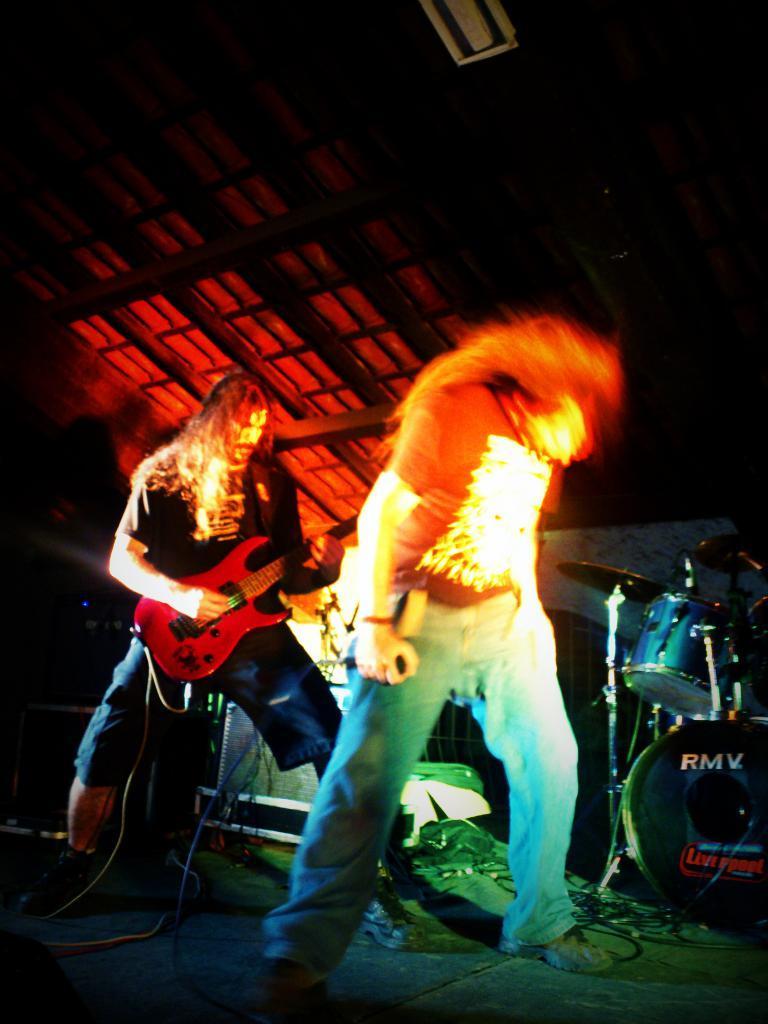Can you describe this image briefly? In this image, there are two people. The one in the front is holding a mic and held his head downwards. His legs are apart. And the other is a Guitarist. He has a long hair which is bit red and looking brownish. And there is slant roof above them. There is a drum set beside the singer. 